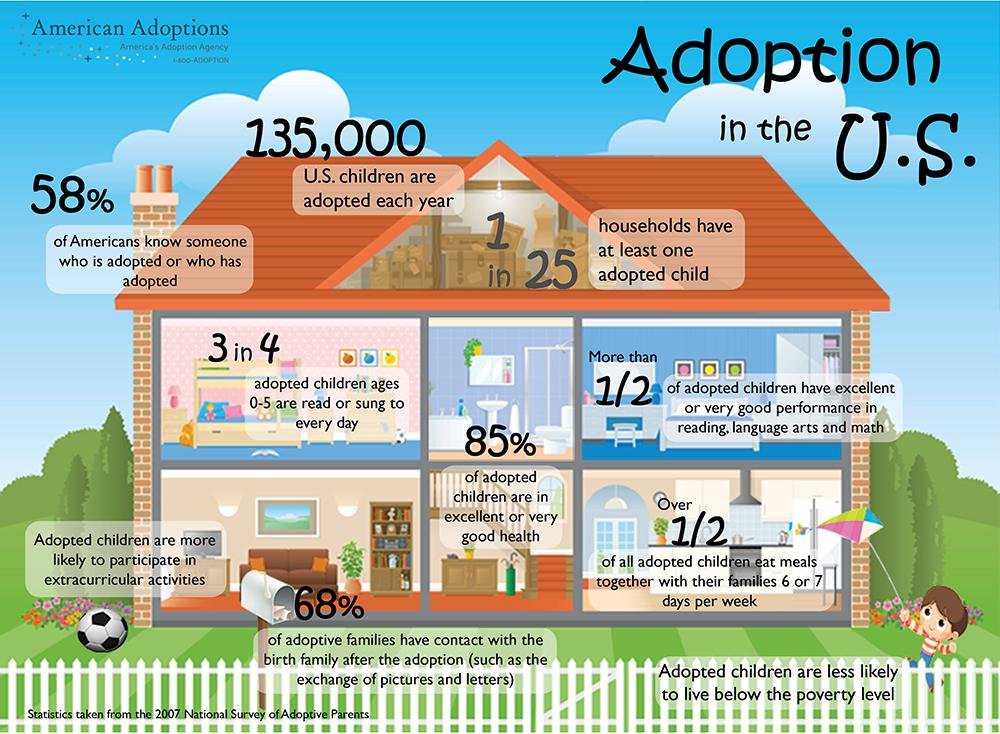Highlight a few significant elements in this photo. According to recent data, 1 in every 25 households has at least one adopted child. Each year in the United States, approximately 135,000 children are adopted. 